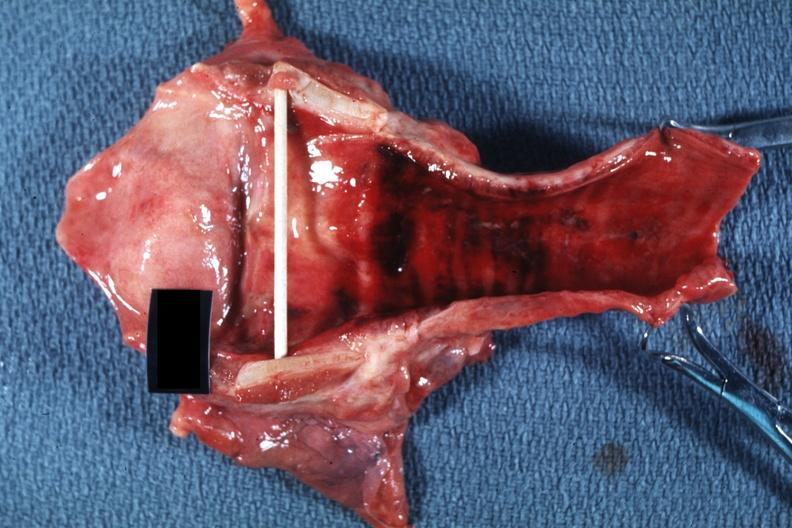what is present?
Answer the question using a single word or phrase. Acute inflammation 